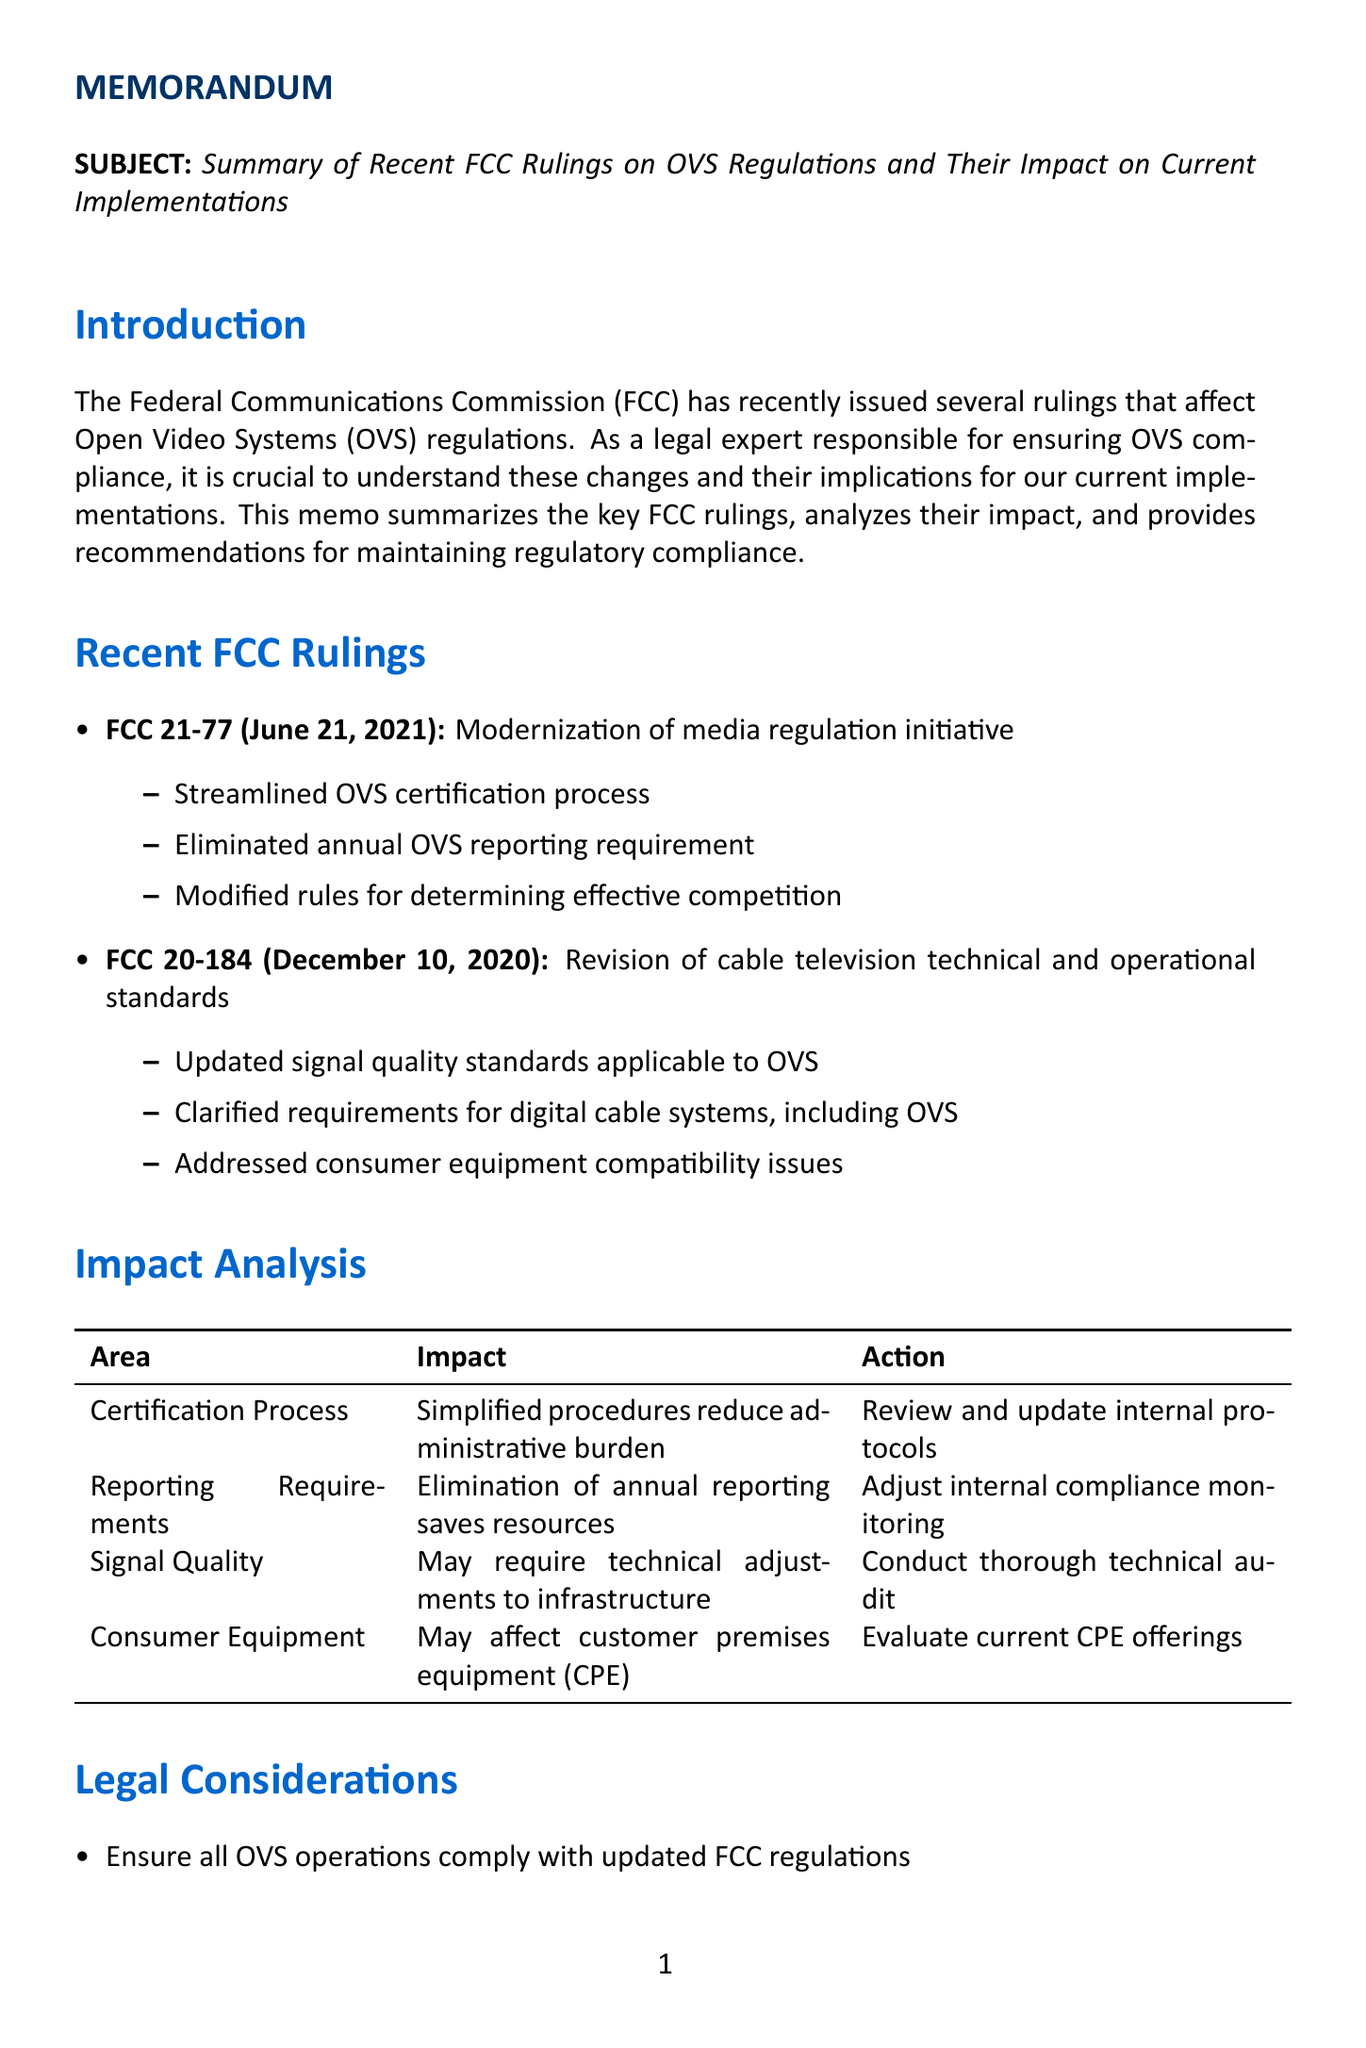What is the title of the memo? The title of the memo is stated at the beginning and mentions FCC rulings on OVS regulations.
Answer: Summary of Recent FCC Rulings on OVS Regulations and Their Impact on Current Implementations When was FCC 21-77 issued? The date of FCC 21-77 is noted in the section summarizing recent rulings.
Answer: June 21, 2021 What is one key point from FCC 21-77? A key point highlights the streamlined certification process for OVS, which is listed under FCC 21-77 details.
Answer: Streamlined OVS certification process What area does the impact analysis mention requires technical adjustments? The impact analysis specifies an area related to signal quality needing adjustments.
Answer: Signal Quality What recommendation is given for staff on new FCC rulings? One of the recommendations focuses on conducting training for staff regarding updated regulations.
Answer: Conduct training sessions for relevant staff on updated OVS regulations What should be established to oversee implementation of regulatory changes? The memo suggests forming a team specifically for oversight of changes in regulations.
Answer: A cross-functional team What is a legal consideration regarding customer agreements? A legal consideration involves updating agreements according to new regulations affecting OVS operations.
Answer: Review and revise customer agreements to reflect new regulatory landscape 